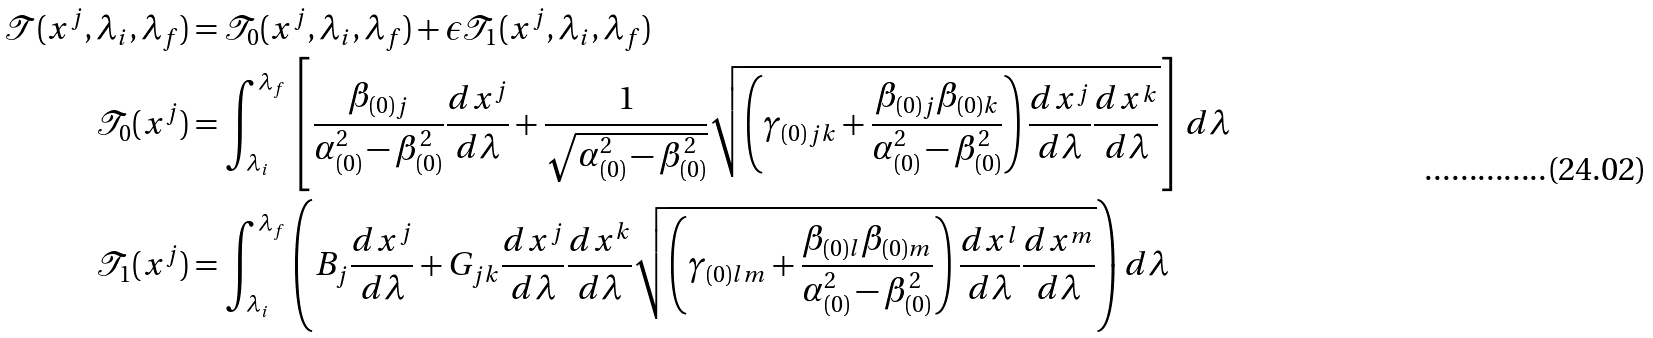<formula> <loc_0><loc_0><loc_500><loc_500>\mathcal { T } ( x ^ { j } , \lambda _ { i } , \lambda _ { f } ) & = \mathcal { T } _ { 0 } ( x ^ { j } , \lambda _ { i } , \lambda _ { f } ) + \epsilon \mathcal { T } _ { 1 } ( x ^ { j } , \lambda _ { i } , \lambda _ { f } ) \\ \mathcal { T } _ { 0 } ( x ^ { j } ) & = \int _ { \lambda _ { i } } ^ { \lambda _ { f } } \left [ \frac { \beta _ { ( 0 ) j } } { \alpha _ { ( 0 ) } ^ { 2 } - \beta _ { ( 0 ) } ^ { 2 } } \frac { d x ^ { j } } { d \lambda } + \frac { 1 } { \sqrt { \alpha _ { ( 0 ) } ^ { 2 } - \beta _ { ( 0 ) } ^ { 2 } } } \sqrt { \left ( \gamma _ { ( 0 ) j k } + \frac { \beta _ { ( 0 ) j } \beta _ { ( 0 ) k } } { \alpha _ { ( 0 ) } ^ { 2 } - \beta _ { ( 0 ) } ^ { 2 } } \right ) \frac { d x ^ { j } } { d \lambda } \frac { d x ^ { k } } { d \lambda } } \right ] d \lambda \\ \mathcal { T } _ { 1 } ( x ^ { j } ) & = \int _ { \lambda _ { i } } ^ { \lambda _ { f } } \left ( B _ { j } \frac { d x ^ { j } } { d \lambda } + G _ { j k } \frac { d x ^ { j } } { d \lambda } \frac { d x ^ { k } } { d \lambda } \sqrt { \left ( \gamma _ { ( 0 ) l m } + \frac { \beta _ { ( 0 ) l } \beta _ { ( 0 ) m } } { \alpha _ { ( 0 ) } ^ { 2 } - \beta _ { ( 0 ) } ^ { 2 } } \right ) \frac { d x ^ { l } } { d \lambda } \frac { d x ^ { m } } { d \lambda } } \right ) d \lambda</formula> 